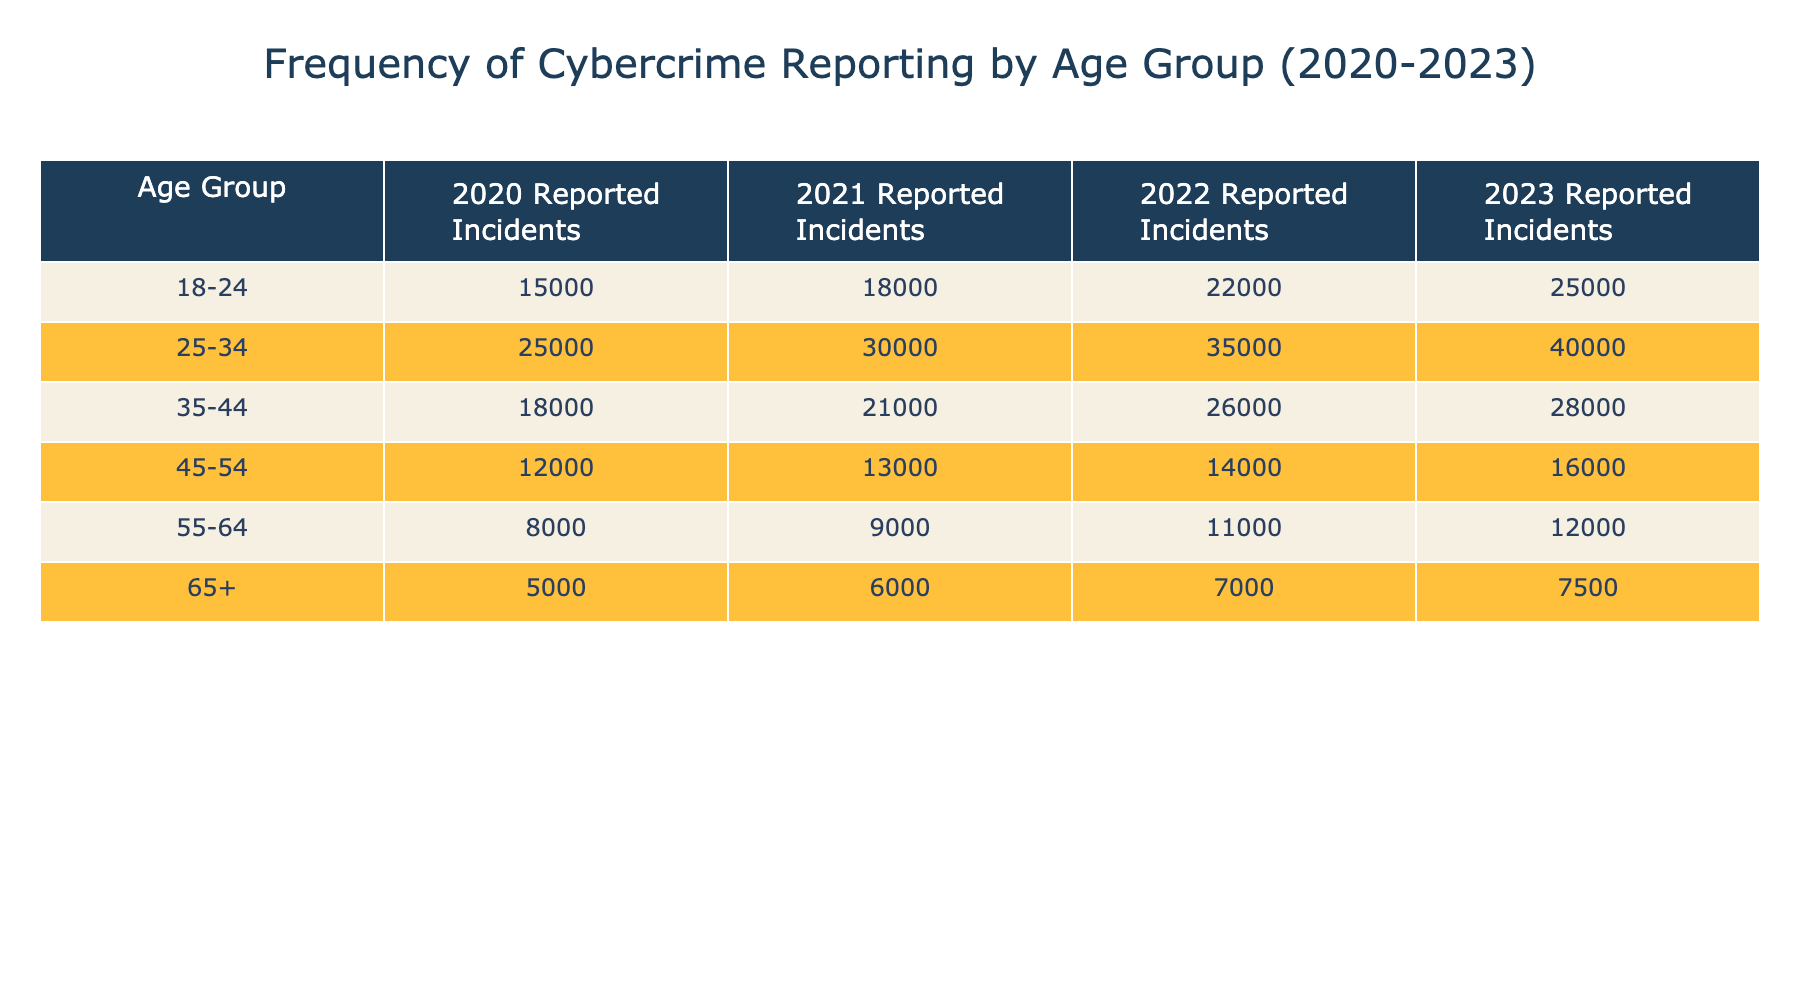What was the reported incident count for the age group 25-34 in 2022? The table shows the column for the year 2022 and the row for the age group 25-34. Referring to the table, the value corresponding to this intersection is 35000.
Answer: 35000 Which age group reported the highest number of incidents in 2023? Looking at the 2023 column across all age groups, the age group 25-34 has the highest reported incidents at 40000.
Answer: 25-34 What is the total number of cybercrime incidents reported by the 18-24 age group from 2020 to 2023? To find the total, I need to add the values from each year: 15000 (2020) + 18000 (2021) + 22000 (2022) + 25000 (2023) = 80000.
Answer: 80000 Did the number of reported incidents for the age group 35-44 decrease in any year from 2020 to 2023? The values for the age group 35-44 are 18000 (2020), 21000 (2021), 26000 (2022), and 28000 (2023). All of these values show an increase each year, therefore the answer is no.
Answer: No What was the average reported incident count for the age group 55-64 over the four years? To calculate the average, I sum the reported incidents: 8000 + 9000 + 11000 + 12000 = 40000. Then, I divide by the number of years, which is 4: 40000 / 4 = 10000.
Answer: 10000 In which year did the 45-54 age group report the least number of incidents? Checking the 45-54 row for reported incidents: 12000 (2020), 13000 (2021), 14000 (2022), and 16000 (2023). The lowest value is 12000 in 2020.
Answer: 2020 What is the percentage increase in reported incidents for the age group 65+ from 2020 to 2023? To determine the percentage increase, I calculate the difference between reported incidents in 2023 (7500) and 2020 (5000), which is 2500. I then divide by the original value (5000) and multiply by 100: (2500 / 5000) * 100 = 50%.
Answer: 50% Is it true that more incidents were reported by the age group 35-44 than the age group 45-54 in all four years? The incidents recorded for 35-44 are 18000, 21000, 26000, and 28000 while for 45-54 they are 12000, 13000, 14000, and 16000. Since all comparisons show 35-44 having higher numbers, the statement is true.
Answer: True Which age group had the lowest increase in reported incidents from 2022 to 2023? Looking at the increase from 2022 to 2023 for each age group: 18-24: 3000, 25-34: 5000, 35-44: 2000, 45-54: 2000, 55-64: 1000, and 65+: 500. The smallest increase is seen in the 65+ age group with 500 incidents.
Answer: 65+ 